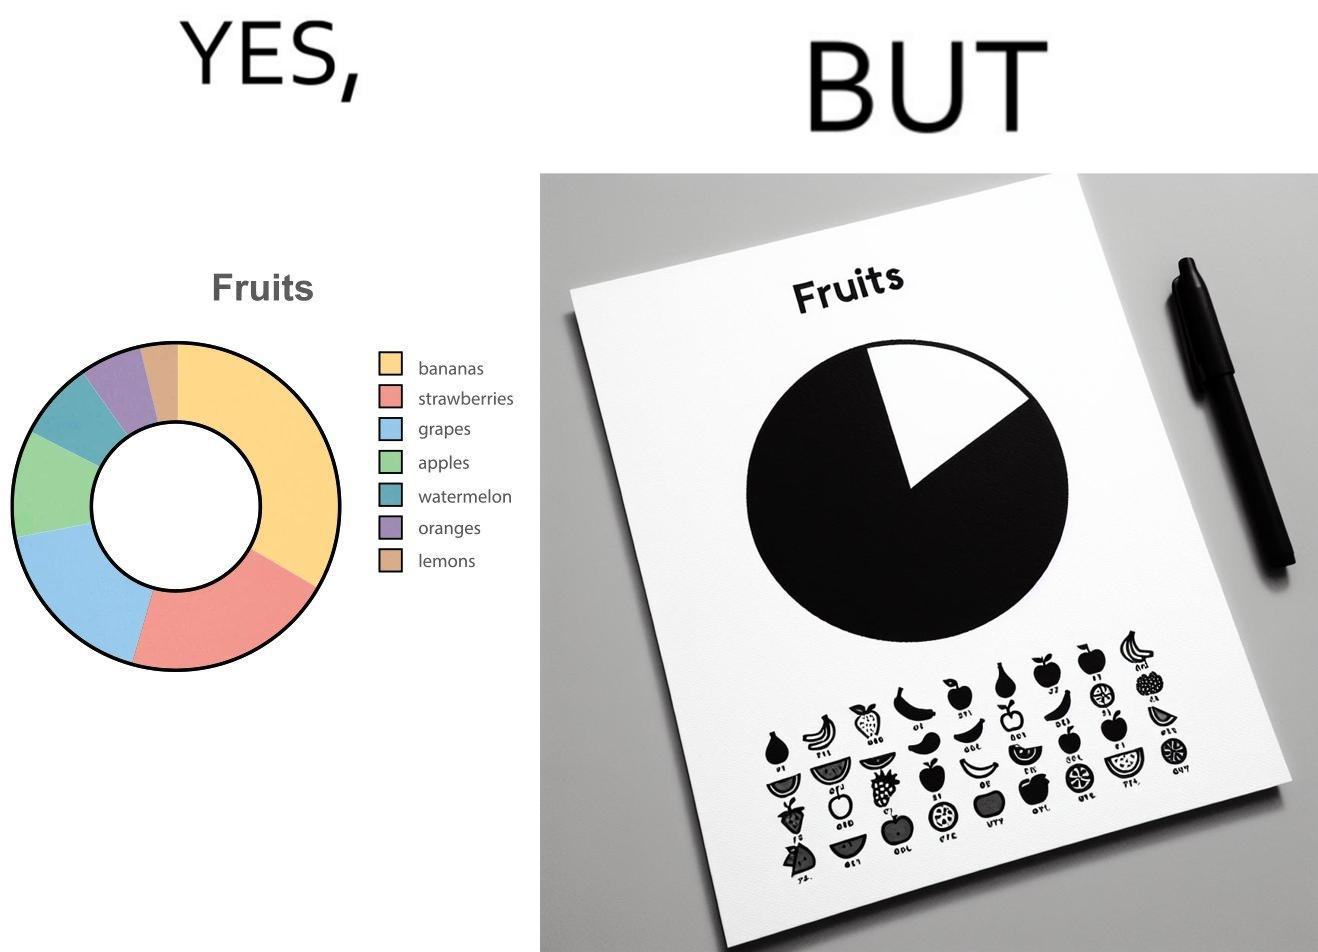Describe the satirical element in this image. This is funny because the pie chart printout is useless as you cant see any divisions on it because the  printer could not capture the different colors 